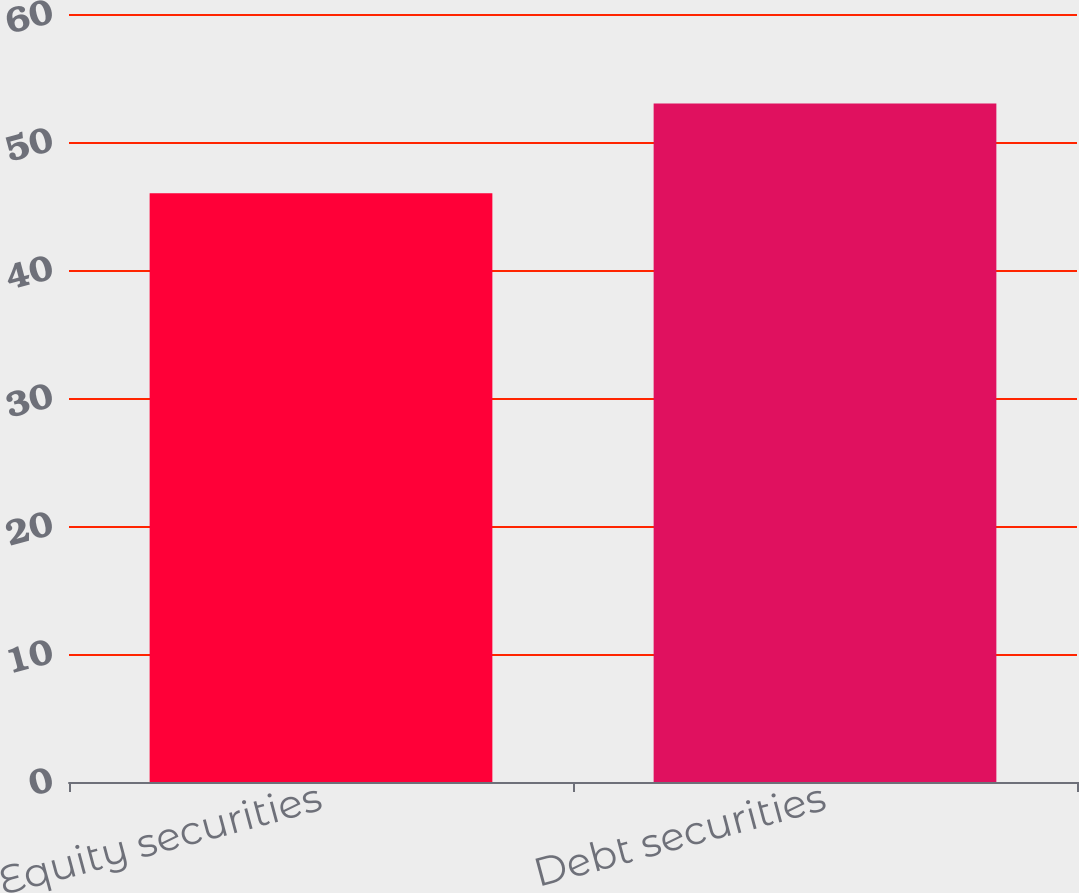Convert chart to OTSL. <chart><loc_0><loc_0><loc_500><loc_500><bar_chart><fcel>Equity securities<fcel>Debt securities<nl><fcel>46<fcel>53<nl></chart> 